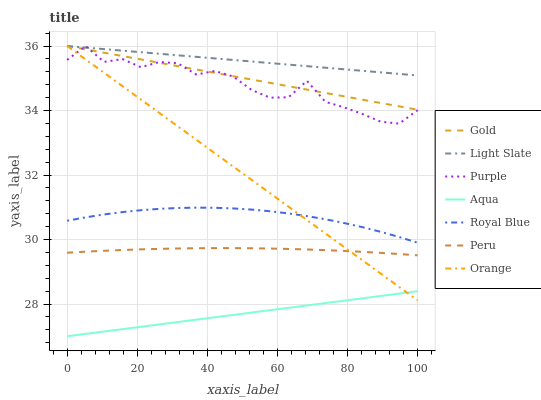Does Royal Blue have the minimum area under the curve?
Answer yes or no. No. Does Royal Blue have the maximum area under the curve?
Answer yes or no. No. Is Royal Blue the smoothest?
Answer yes or no. No. Is Royal Blue the roughest?
Answer yes or no. No. Does Royal Blue have the lowest value?
Answer yes or no. No. Does Royal Blue have the highest value?
Answer yes or no. No. Is Peru less than Purple?
Answer yes or no. Yes. Is Peru greater than Aqua?
Answer yes or no. Yes. Does Peru intersect Purple?
Answer yes or no. No. 